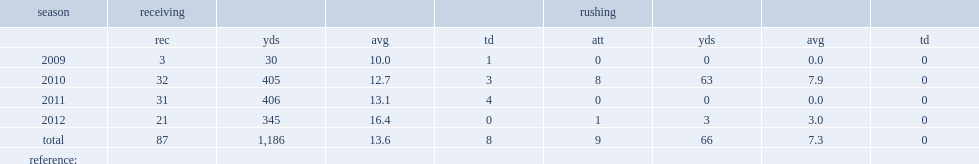In 2010, how many yards did jaron brown score per reception? 12.7. 